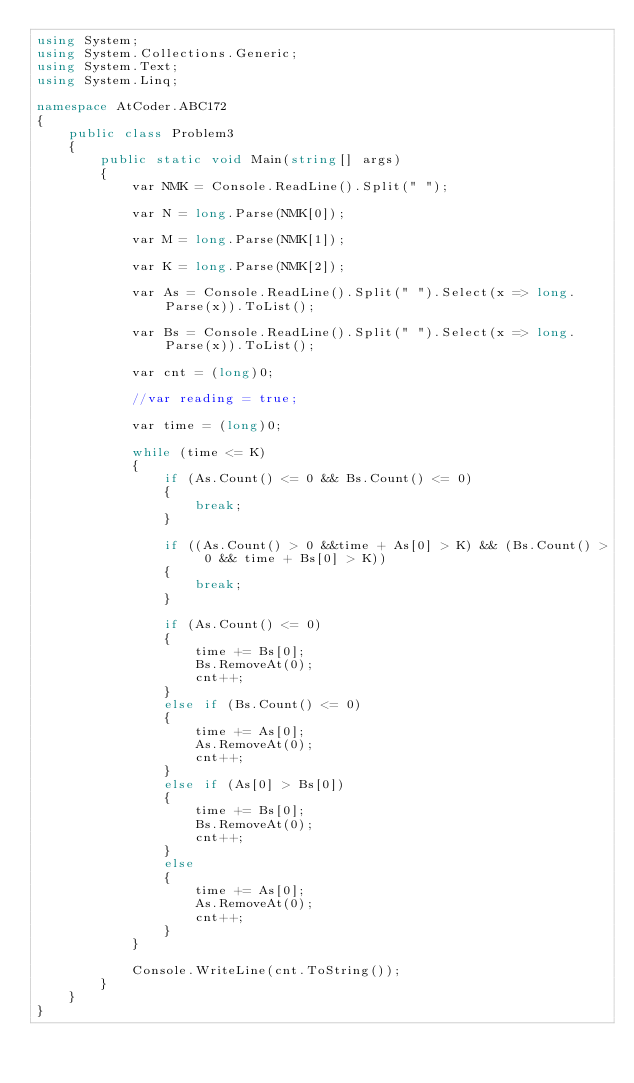Convert code to text. <code><loc_0><loc_0><loc_500><loc_500><_C#_>using System;
using System.Collections.Generic;
using System.Text;
using System.Linq;

namespace AtCoder.ABC172
{
    public class Problem3
    {
        public static void Main(string[] args)
        {
            var NMK = Console.ReadLine().Split(" ");

            var N = long.Parse(NMK[0]);

            var M = long.Parse(NMK[1]);

            var K = long.Parse(NMK[2]);

            var As = Console.ReadLine().Split(" ").Select(x => long.Parse(x)).ToList();

            var Bs = Console.ReadLine().Split(" ").Select(x => long.Parse(x)).ToList();

            var cnt = (long)0;

            //var reading = true;

            var time = (long)0;

            while (time <= K)
            {
                if (As.Count() <= 0 && Bs.Count() <= 0)
                {
                    break;
                }
                
                if ((As.Count() > 0 &&time + As[0] > K) && (Bs.Count() > 0 && time + Bs[0] > K)) 
                {
                    break;
                }
                
                if (As.Count() <= 0)
                {
                    time += Bs[0];
                    Bs.RemoveAt(0);
                    cnt++;
                }
                else if (Bs.Count() <= 0)
                {
                    time += As[0];
                    As.RemoveAt(0);
                    cnt++;
                }
                else if (As[0] > Bs[0])
                {
                    time += Bs[0];
                    Bs.RemoveAt(0);
                    cnt++;
                }
                else
                {
                    time += As[0];
                    As.RemoveAt(0);
                    cnt++;
                }
            }

            Console.WriteLine(cnt.ToString());
        }
    }
}
</code> 